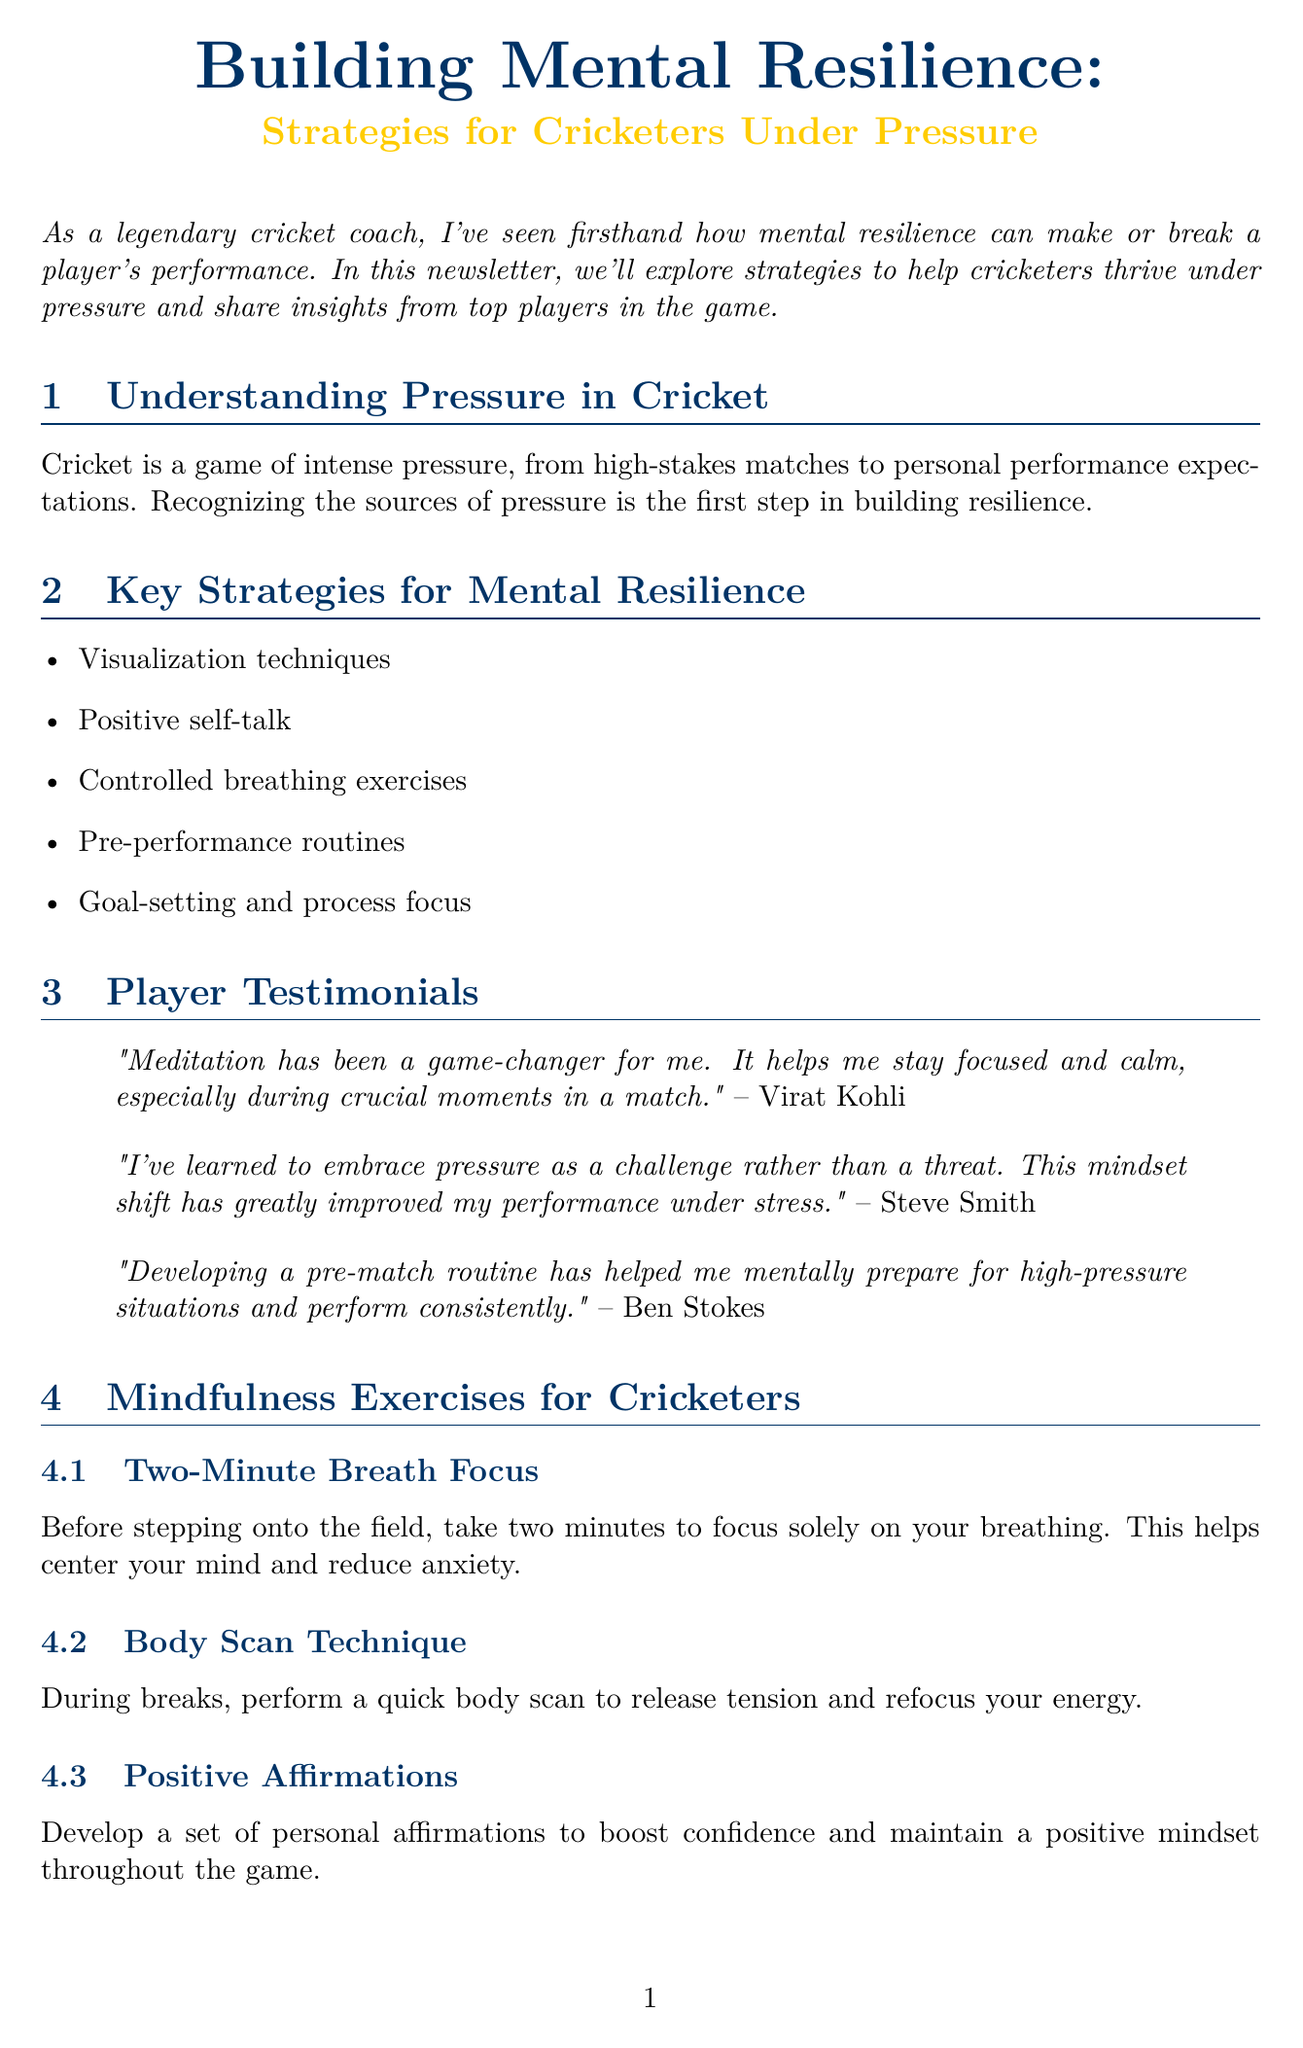What is the title of the newsletter? The title is explicitly stated at the beginning of the document.
Answer: Building Mental Resilience: Strategies for Cricketers Under Pressure What is one key strategy mentioned for mental resilience? The document lists key strategies in a specific section.
Answer: Visualization techniques Who quoted "Meditation has been a game-changer for me"? The document includes player testimonials with specific quotes.
Answer: Virat Kohli What exercise involves focusing solely on breathing for two minutes? The mindfulness exercises section describes various techniques, one of which is highlighted here.
Answer: Two-Minute Breath Focus What major cricket event is analyzed in the newsletter? The document refers to a specific case study related to a cricket event.
Answer: 2019 Cricket World Cup Final What mindset shift did Steve Smith learn to embrace? The document mentions what Steve Smith believes about pressure in his testimonial.
Answer: Challenge rather than a threat What is the coaching tip mentioned in the newsletter? The document provides a special coaching tip towards the end.
Answer: Consistent practice and dedication What quote is attributed to Bryce Courtenay? The closing quote at the end of the document is from Bryce Courtenay.
Answer: "The mind is the athlete..." How many mindfulness exercises are listed in the document? The exercises section enumerates specific techniques for mindfulness.
Answer: Three 